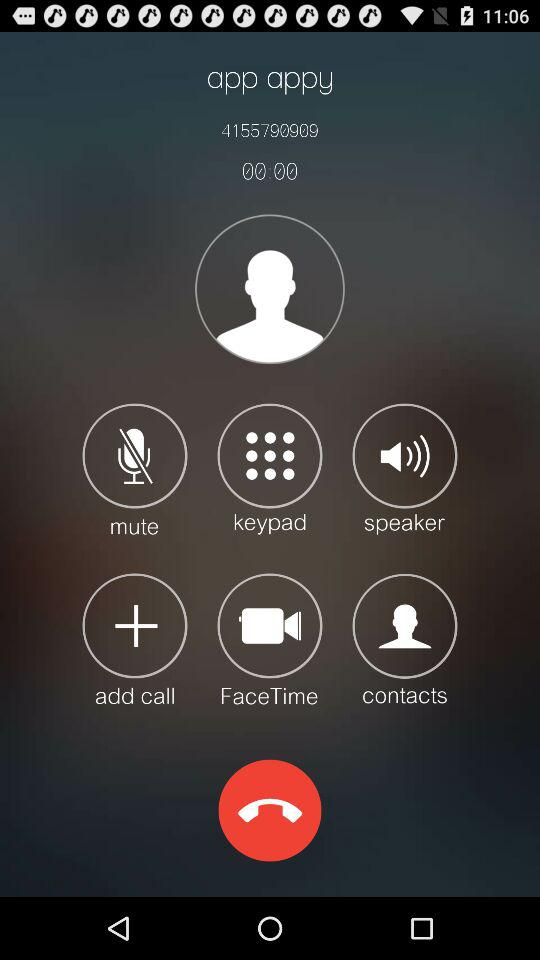What is the dialed mobile number? The mobile number is 4155790909. 